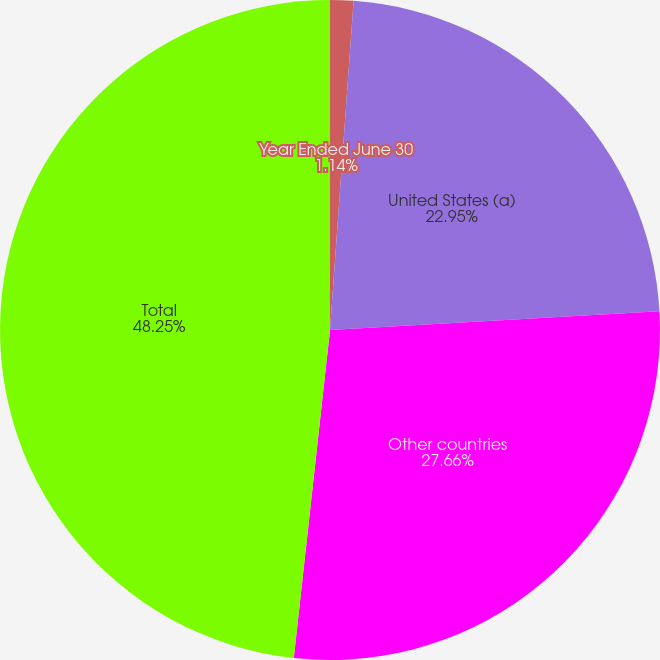<chart> <loc_0><loc_0><loc_500><loc_500><pie_chart><fcel>Year Ended June 30<fcel>United States (a)<fcel>Other countries<fcel>Total<nl><fcel>1.14%<fcel>22.95%<fcel>27.66%<fcel>48.25%<nl></chart> 